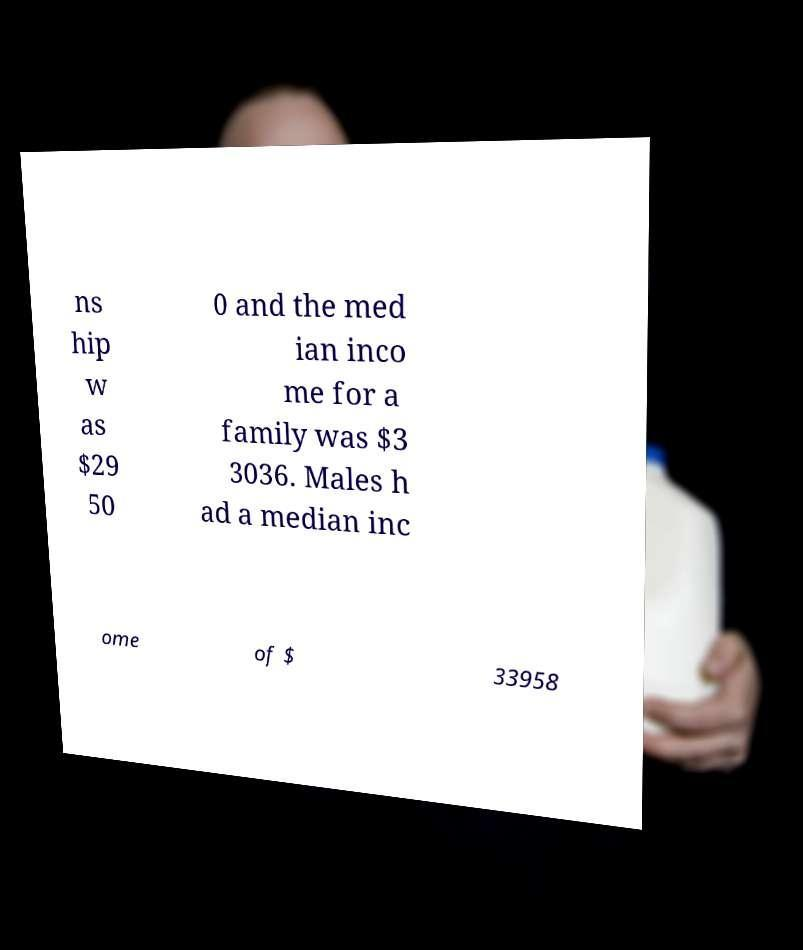Could you extract and type out the text from this image? ns hip w as $29 50 0 and the med ian inco me for a family was $3 3036. Males h ad a median inc ome of $ 33958 